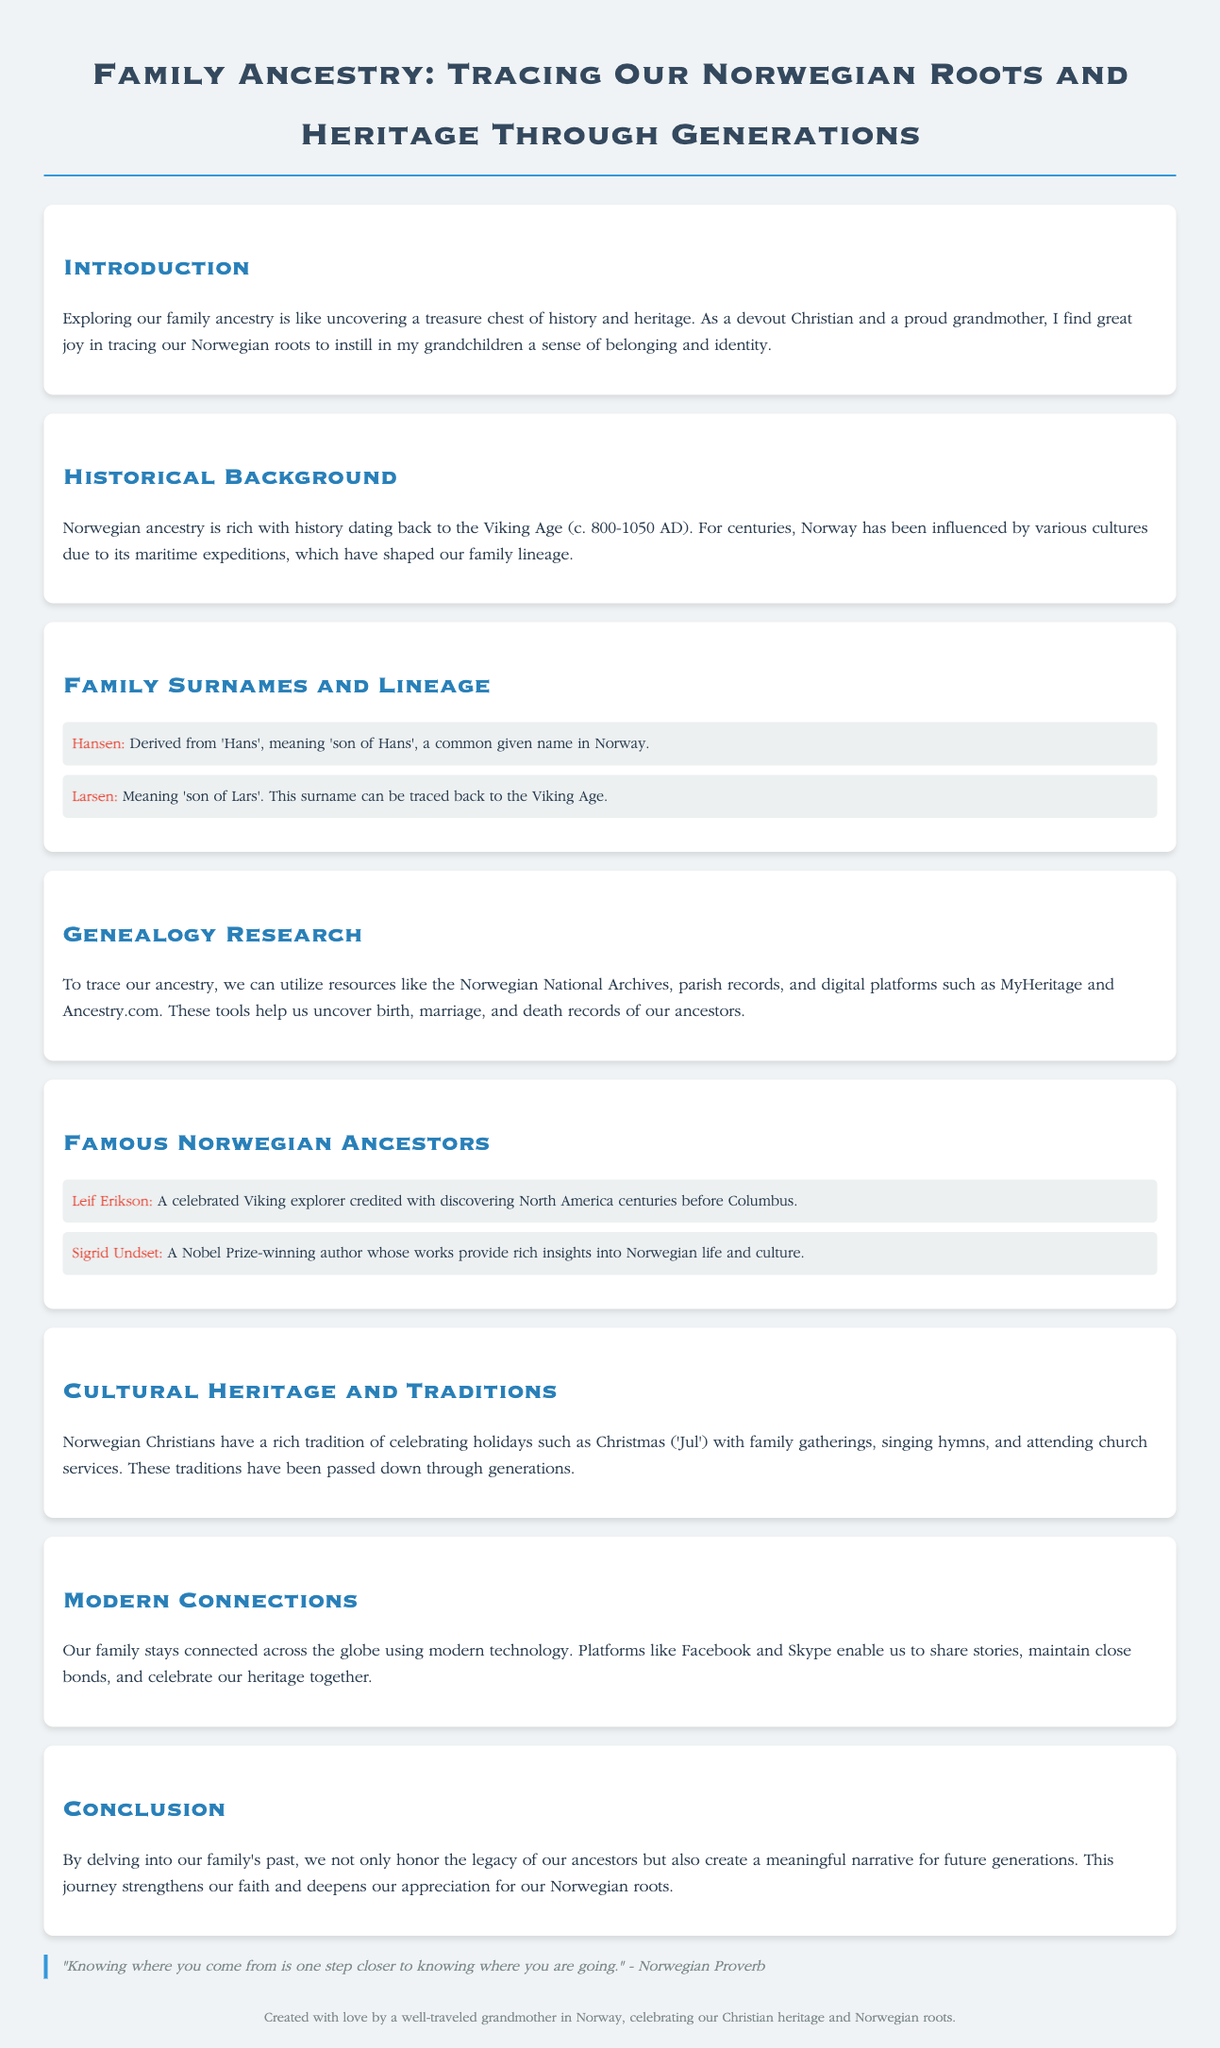What is the title of the document? The title is clearly stated at the top of the document as "Family Ancestry: Tracing Our Norwegian Roots and Heritage Through Generations."
Answer: Family Ancestry: Tracing Our Norwegian Roots and Heritage Through Generations Who is highlighted as a famous Viking explorer? The document lists Leif Erikson as a celebrated Viking explorer credited with discovering North America.
Answer: Leif Erikson What does the surname "Hansen" mean? The document explains that "Hansen" is derived from 'Hans', meaning 'son of Hans'.
Answer: son of Hans Which two digital platforms are suggested for genealogy research? The document mentions MyHeritage and Ancestry.com as resources for genealogy research.
Answer: MyHeritage and Ancestry.com What historical period does the document associate with Norwegian ancestry? The text states that Norwegian ancestry dates back to the Viking Age (c. 800-1050 AD).
Answer: Viking Age What is considered a key tradition in Norwegian Christian culture during Christmas? The text mentions family gatherings, singing hymns, and attending church services as traditions during Christmas.
Answer: family gatherings How does the document describe the importance of exploring family ancestry? The introduction conveys that exploring family ancestry is like uncovering a treasure chest of history and heritage.
Answer: uncovering a treasure chest of history and heritage What phrase encapsulates the essence of knowing one’s roots in the document? The document includes a Norwegian proverb that emphasizes the link between knowing where you come from and where you're going.
Answer: "Knowing where you come from is one step closer to knowing where you are going." 